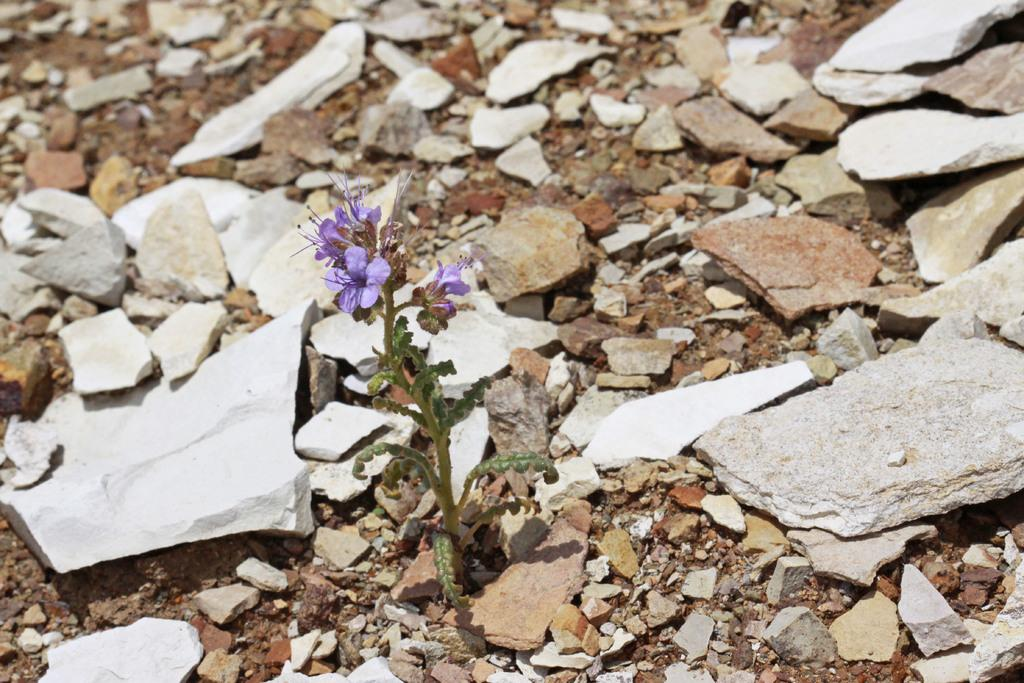What type of objects can be seen in the image? There are stones in the image. What type of living organism is present in the image? There is a plant in the image. What can be observed on the plant? Flowers are grown on the plant. What type of experience does the plant have with the stones in the image? There is no indication in the image that the plant has any experience with the stones, as plants do not have the ability to experience things in the same way as humans or animals. 